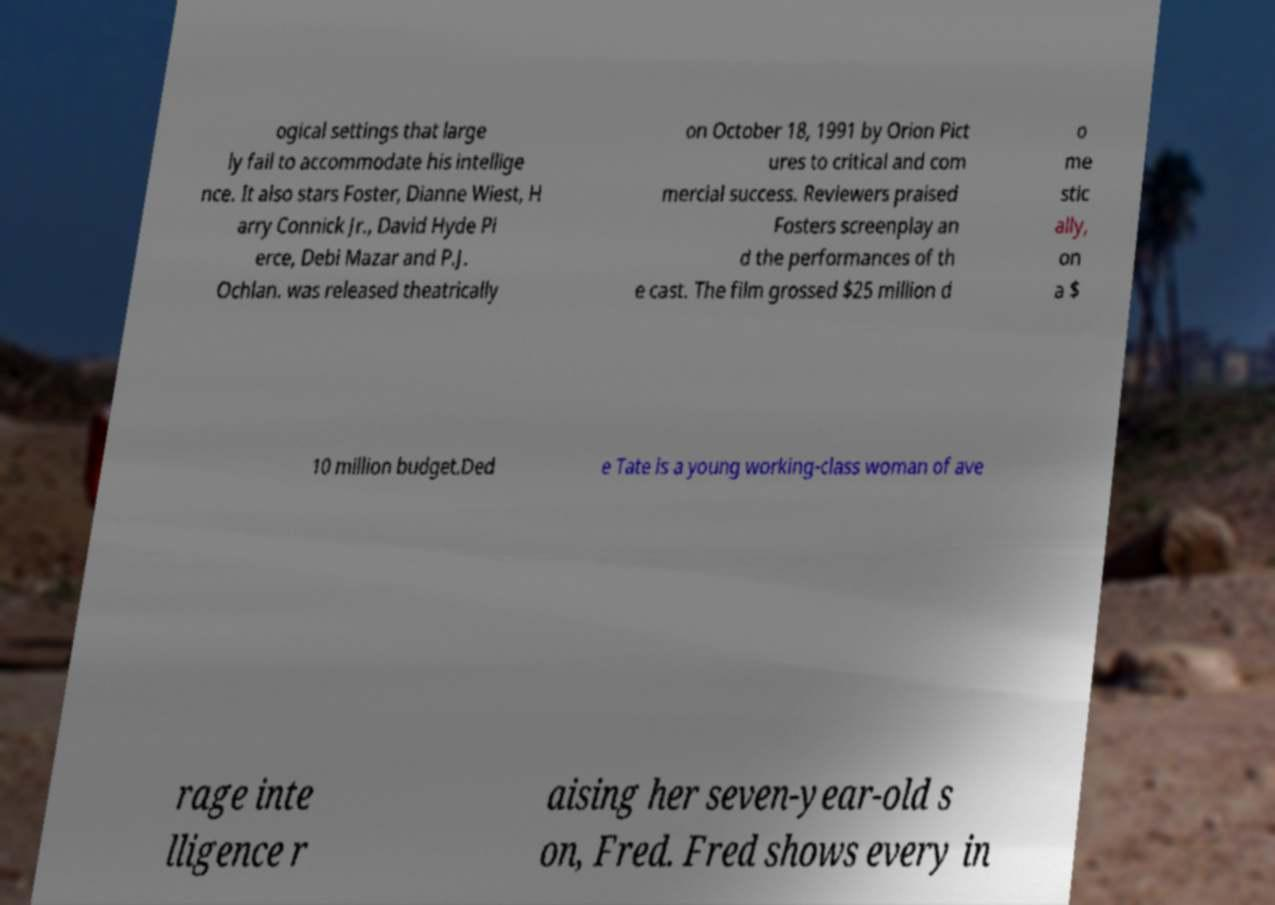Could you assist in decoding the text presented in this image and type it out clearly? ogical settings that large ly fail to accommodate his intellige nce. It also stars Foster, Dianne Wiest, H arry Connick Jr., David Hyde Pi erce, Debi Mazar and P.J. Ochlan. was released theatrically on October 18, 1991 by Orion Pict ures to critical and com mercial success. Reviewers praised Fosters screenplay an d the performances of th e cast. The film grossed $25 million d o me stic ally, on a $ 10 million budget.Ded e Tate is a young working-class woman of ave rage inte lligence r aising her seven-year-old s on, Fred. Fred shows every in 